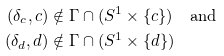<formula> <loc_0><loc_0><loc_500><loc_500>( \delta _ { c } , c ) & \notin \Gamma \cap ( S ^ { 1 } \times \{ c \} ) \quad \text {and} \\ ( \delta _ { d } , d ) & \notin \Gamma \cap ( S ^ { 1 } \times \{ d \} )</formula> 